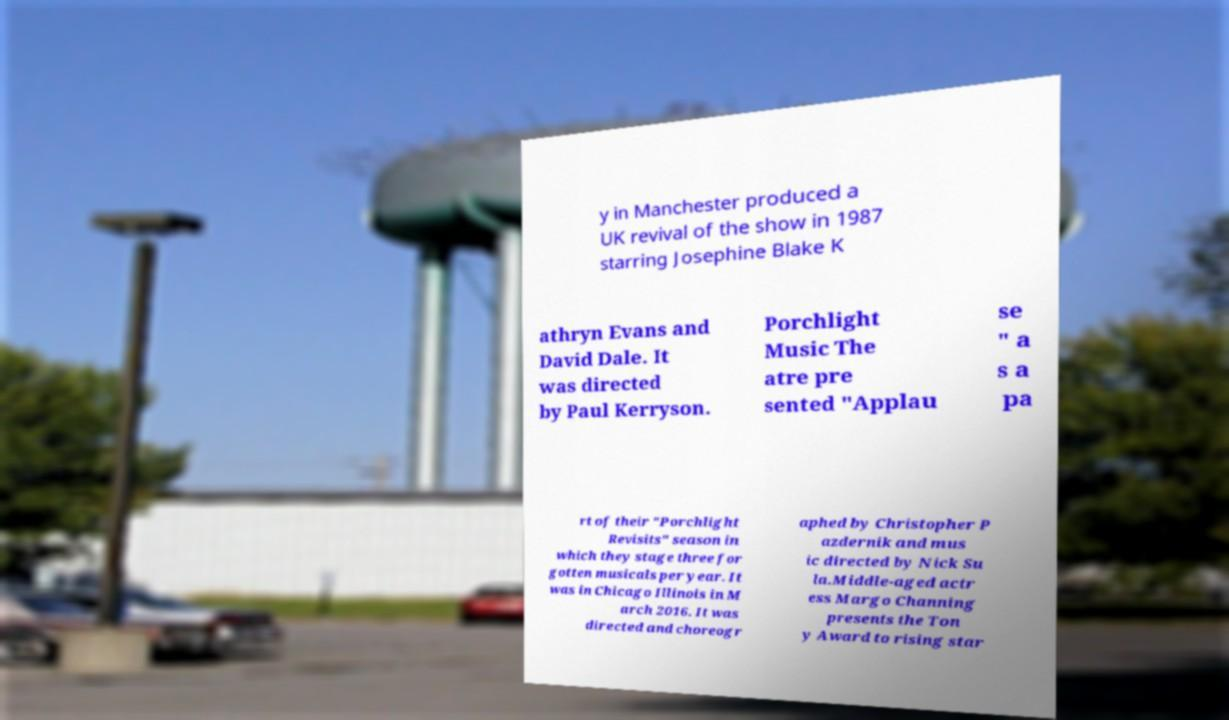For documentation purposes, I need the text within this image transcribed. Could you provide that? y in Manchester produced a UK revival of the show in 1987 starring Josephine Blake K athryn Evans and David Dale. It was directed by Paul Kerryson. Porchlight Music The atre pre sented "Applau se " a s a pa rt of their "Porchlight Revisits" season in which they stage three for gotten musicals per year. It was in Chicago Illinois in M arch 2016. It was directed and choreogr aphed by Christopher P azdernik and mus ic directed by Nick Su la.Middle-aged actr ess Margo Channing presents the Ton y Award to rising star 